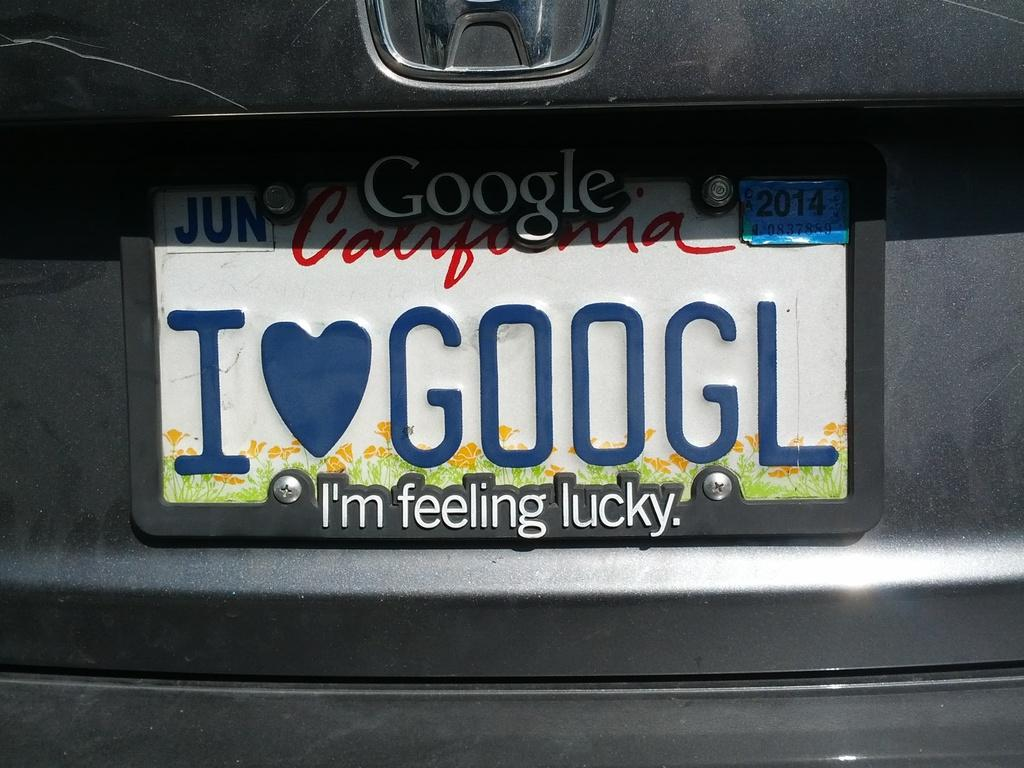<image>
Present a compact description of the photo's key features. "I heart Googl" is being used on the rear license plate of this vehicle. 